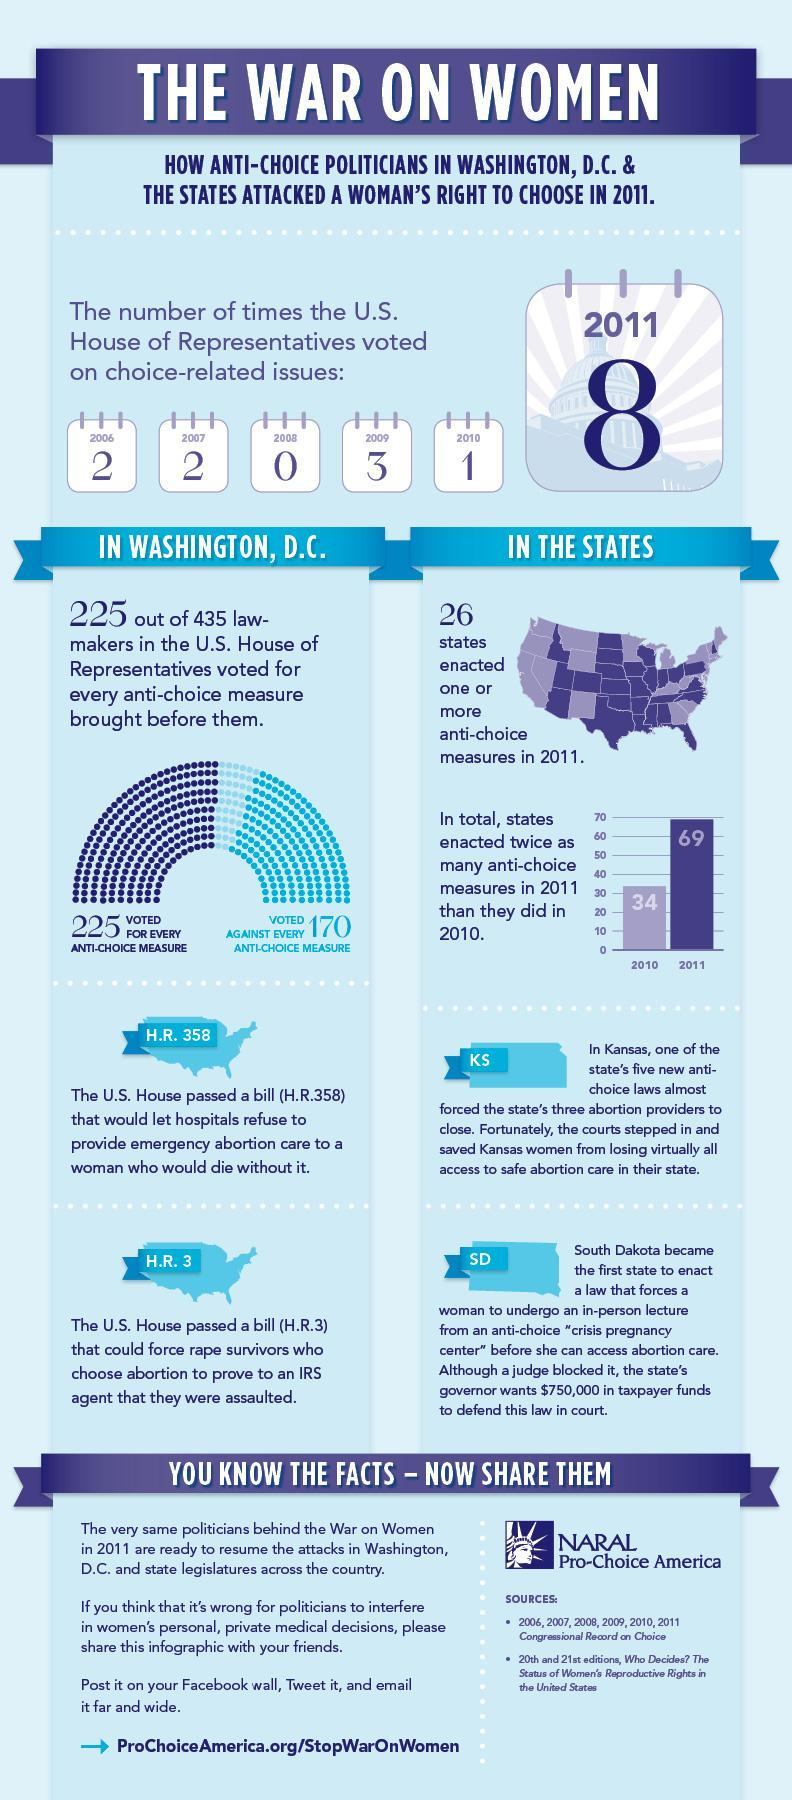How many times did the US House of Representatives vote on choice-related issues in 2010?
Answer the question with a short phrase. 1 How many lawmakers voted against every anti-choice measure brought before them? 170 Which state tried to shut down the abortion providers? Kansas How many 'anti-choice measures' were enacted in 2011? 69 Which US bill did not allow emergency abortion for women whose life depended on it? H.R. 358 In which year was a higher number of 'anti-choice measures' enacted, 2010 or 2011? 2011 What did majority of the lawmakers vote, for anti-choice measures or against anti-choice measures? For anti-choice measures How many 'anti-choice measures' were enacted in 2010? 34 In which year was the highest number of votes on choice-related issues made? 2011 How many "states", enacted anti-choice measures in 2011? 26 Which US bill required women to submit a proof of rape for an abortion? H.R. 3 Which state made it mandatory for women to attend an in-person lecture prior to abortion? South Dakota In which year was 0 votes made on choice-related issues? 2008 